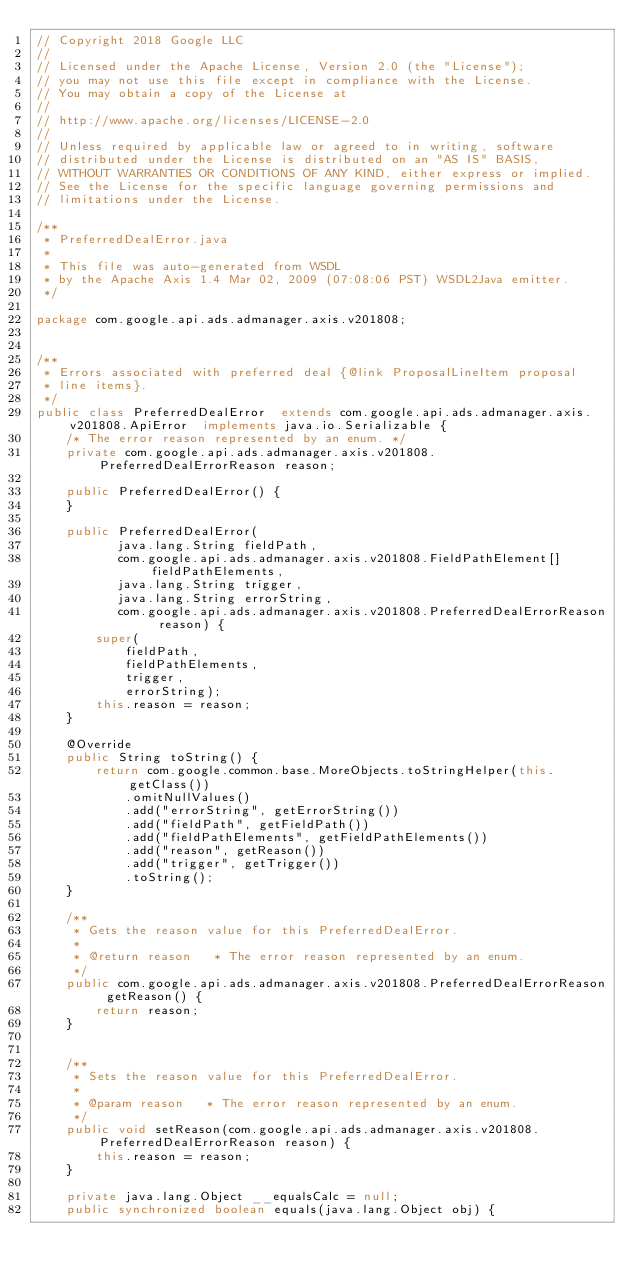<code> <loc_0><loc_0><loc_500><loc_500><_Java_>// Copyright 2018 Google LLC
//
// Licensed under the Apache License, Version 2.0 (the "License");
// you may not use this file except in compliance with the License.
// You may obtain a copy of the License at
//
// http://www.apache.org/licenses/LICENSE-2.0
//
// Unless required by applicable law or agreed to in writing, software
// distributed under the License is distributed on an "AS IS" BASIS,
// WITHOUT WARRANTIES OR CONDITIONS OF ANY KIND, either express or implied.
// See the License for the specific language governing permissions and
// limitations under the License.

/**
 * PreferredDealError.java
 *
 * This file was auto-generated from WSDL
 * by the Apache Axis 1.4 Mar 02, 2009 (07:08:06 PST) WSDL2Java emitter.
 */

package com.google.api.ads.admanager.axis.v201808;


/**
 * Errors associated with preferred deal {@link ProposalLineItem proposal
 * line items}.
 */
public class PreferredDealError  extends com.google.api.ads.admanager.axis.v201808.ApiError  implements java.io.Serializable {
    /* The error reason represented by an enum. */
    private com.google.api.ads.admanager.axis.v201808.PreferredDealErrorReason reason;

    public PreferredDealError() {
    }

    public PreferredDealError(
           java.lang.String fieldPath,
           com.google.api.ads.admanager.axis.v201808.FieldPathElement[] fieldPathElements,
           java.lang.String trigger,
           java.lang.String errorString,
           com.google.api.ads.admanager.axis.v201808.PreferredDealErrorReason reason) {
        super(
            fieldPath,
            fieldPathElements,
            trigger,
            errorString);
        this.reason = reason;
    }

    @Override
    public String toString() {
        return com.google.common.base.MoreObjects.toStringHelper(this.getClass())
            .omitNullValues()
            .add("errorString", getErrorString())
            .add("fieldPath", getFieldPath())
            .add("fieldPathElements", getFieldPathElements())
            .add("reason", getReason())
            .add("trigger", getTrigger())
            .toString();
    }

    /**
     * Gets the reason value for this PreferredDealError.
     * 
     * @return reason   * The error reason represented by an enum.
     */
    public com.google.api.ads.admanager.axis.v201808.PreferredDealErrorReason getReason() {
        return reason;
    }


    /**
     * Sets the reason value for this PreferredDealError.
     * 
     * @param reason   * The error reason represented by an enum.
     */
    public void setReason(com.google.api.ads.admanager.axis.v201808.PreferredDealErrorReason reason) {
        this.reason = reason;
    }

    private java.lang.Object __equalsCalc = null;
    public synchronized boolean equals(java.lang.Object obj) {</code> 